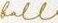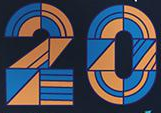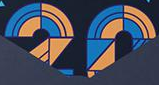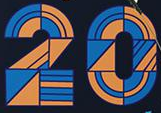Read the text content from these images in order, separated by a semicolon. foll; 20; 20; 20 